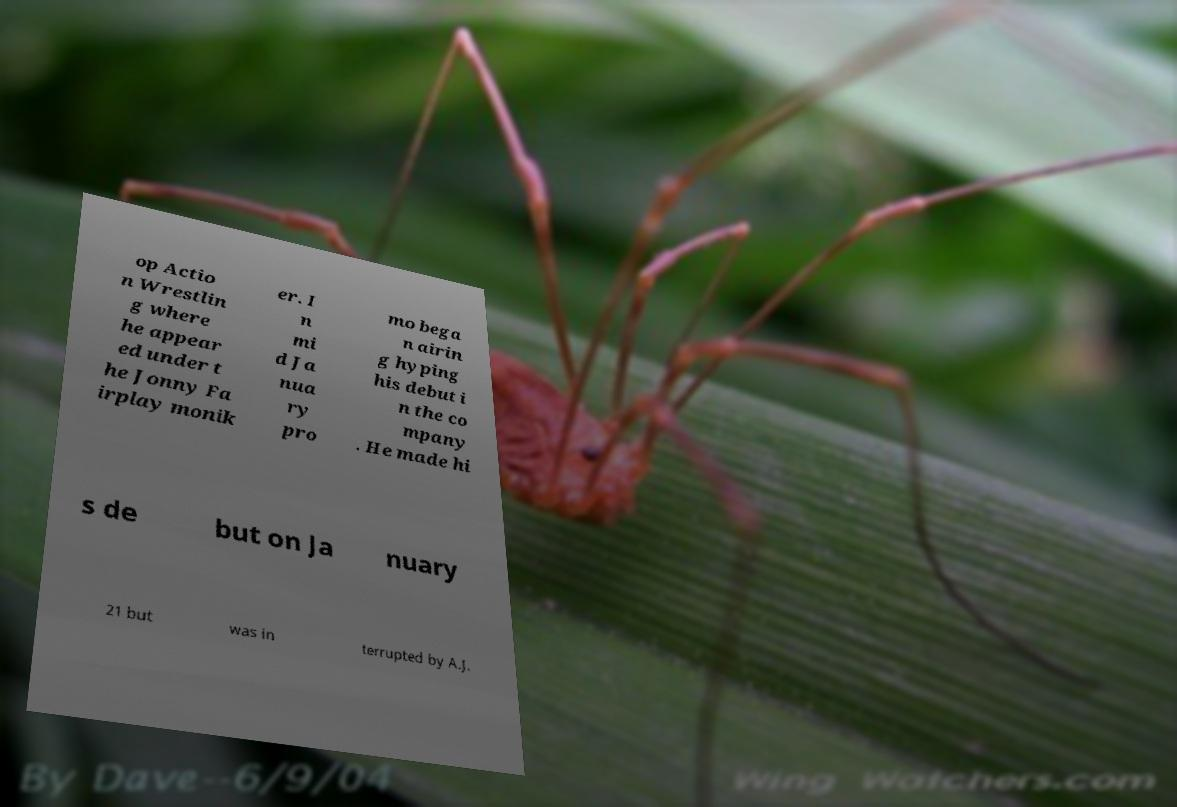I need the written content from this picture converted into text. Can you do that? op Actio n Wrestlin g where he appear ed under t he Jonny Fa irplay monik er. I n mi d Ja nua ry pro mo bega n airin g hyping his debut i n the co mpany . He made hi s de but on Ja nuary 21 but was in terrupted by A.J. 